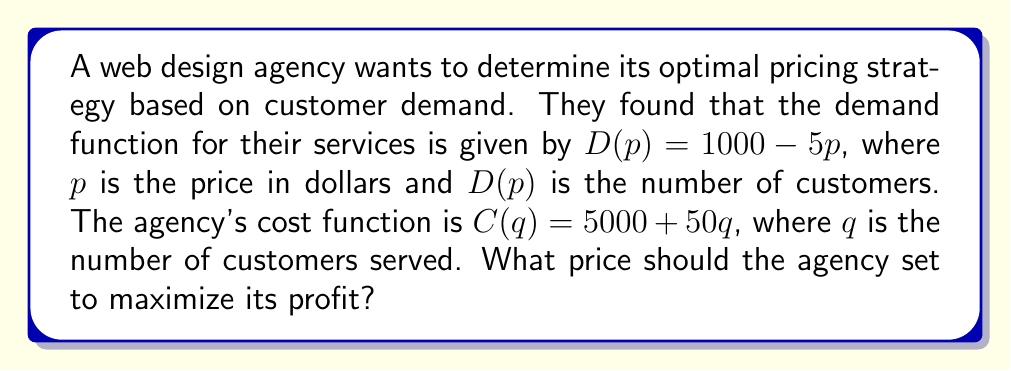Can you solve this math problem? 1. Define the profit function:
   Profit = Revenue - Cost
   $\Pi(p) = pD(p) - C(D(p))$

2. Substitute the given functions:
   $\Pi(p) = p(1000 - 5p) - (5000 + 50(1000 - 5p))$

3. Expand the equation:
   $\Pi(p) = 1000p - 5p^2 - 5000 - 50000 + 250p$
   $\Pi(p) = -5p^2 + 1250p - 55000$

4. To find the maximum profit, differentiate $\Pi(p)$ with respect to $p$ and set it to zero:
   $\frac{d\Pi}{dp} = -10p + 1250 = 0$

5. Solve for $p$:
   $-10p = -1250$
   $p = 125$

6. Verify it's a maximum by checking the second derivative:
   $\frac{d^2\Pi}{dp^2} = -10 < 0$, confirming a maximum

7. Calculate the optimal quantity:
   $q = D(125) = 1000 - 5(125) = 375$

8. Calculate the maximum profit:
   $\Pi(125) = 125(375) - (5000 + 50(375)) = 46,875 - 23,750 = 23,125$
Answer: $125 